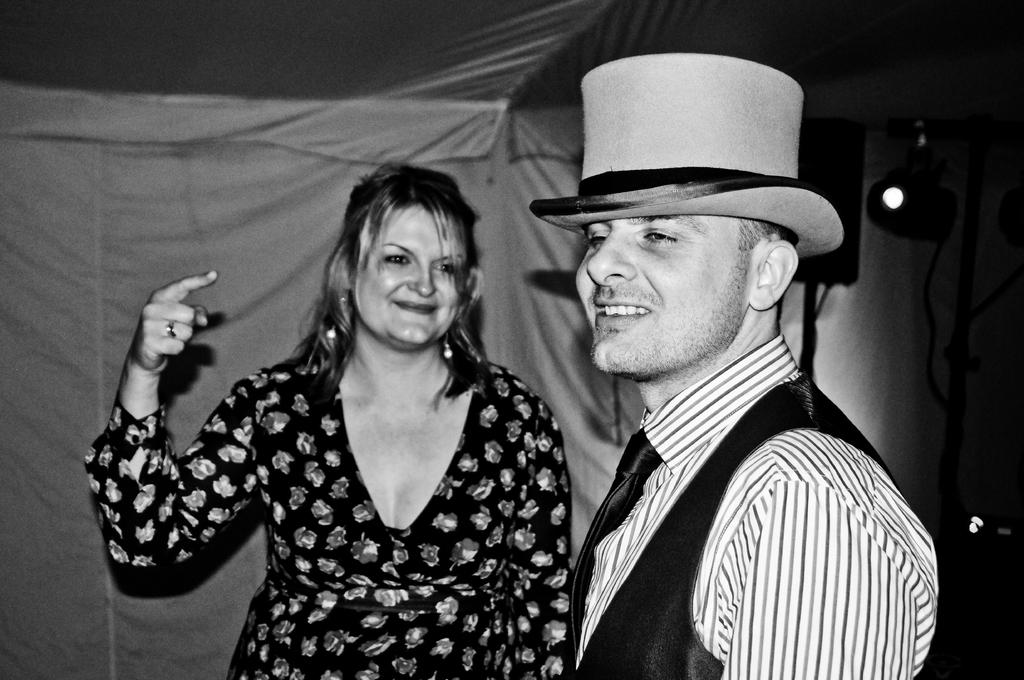What is the color scheme of the image? The image is monochrome. How many people are in the image? There are two persons in the image. Where are the persons located in the image? The persons are standing under a tent. What is the facial expression of the persons? The persons are smiling. What can be seen in the background of the image? There is a speaker and a light in the background. What type of account is being discussed by the persons in the image? There is no indication in the image that the persons are discussing any type of account. Is there a pipe visible in the image? No, there is no pipe present in the image. 